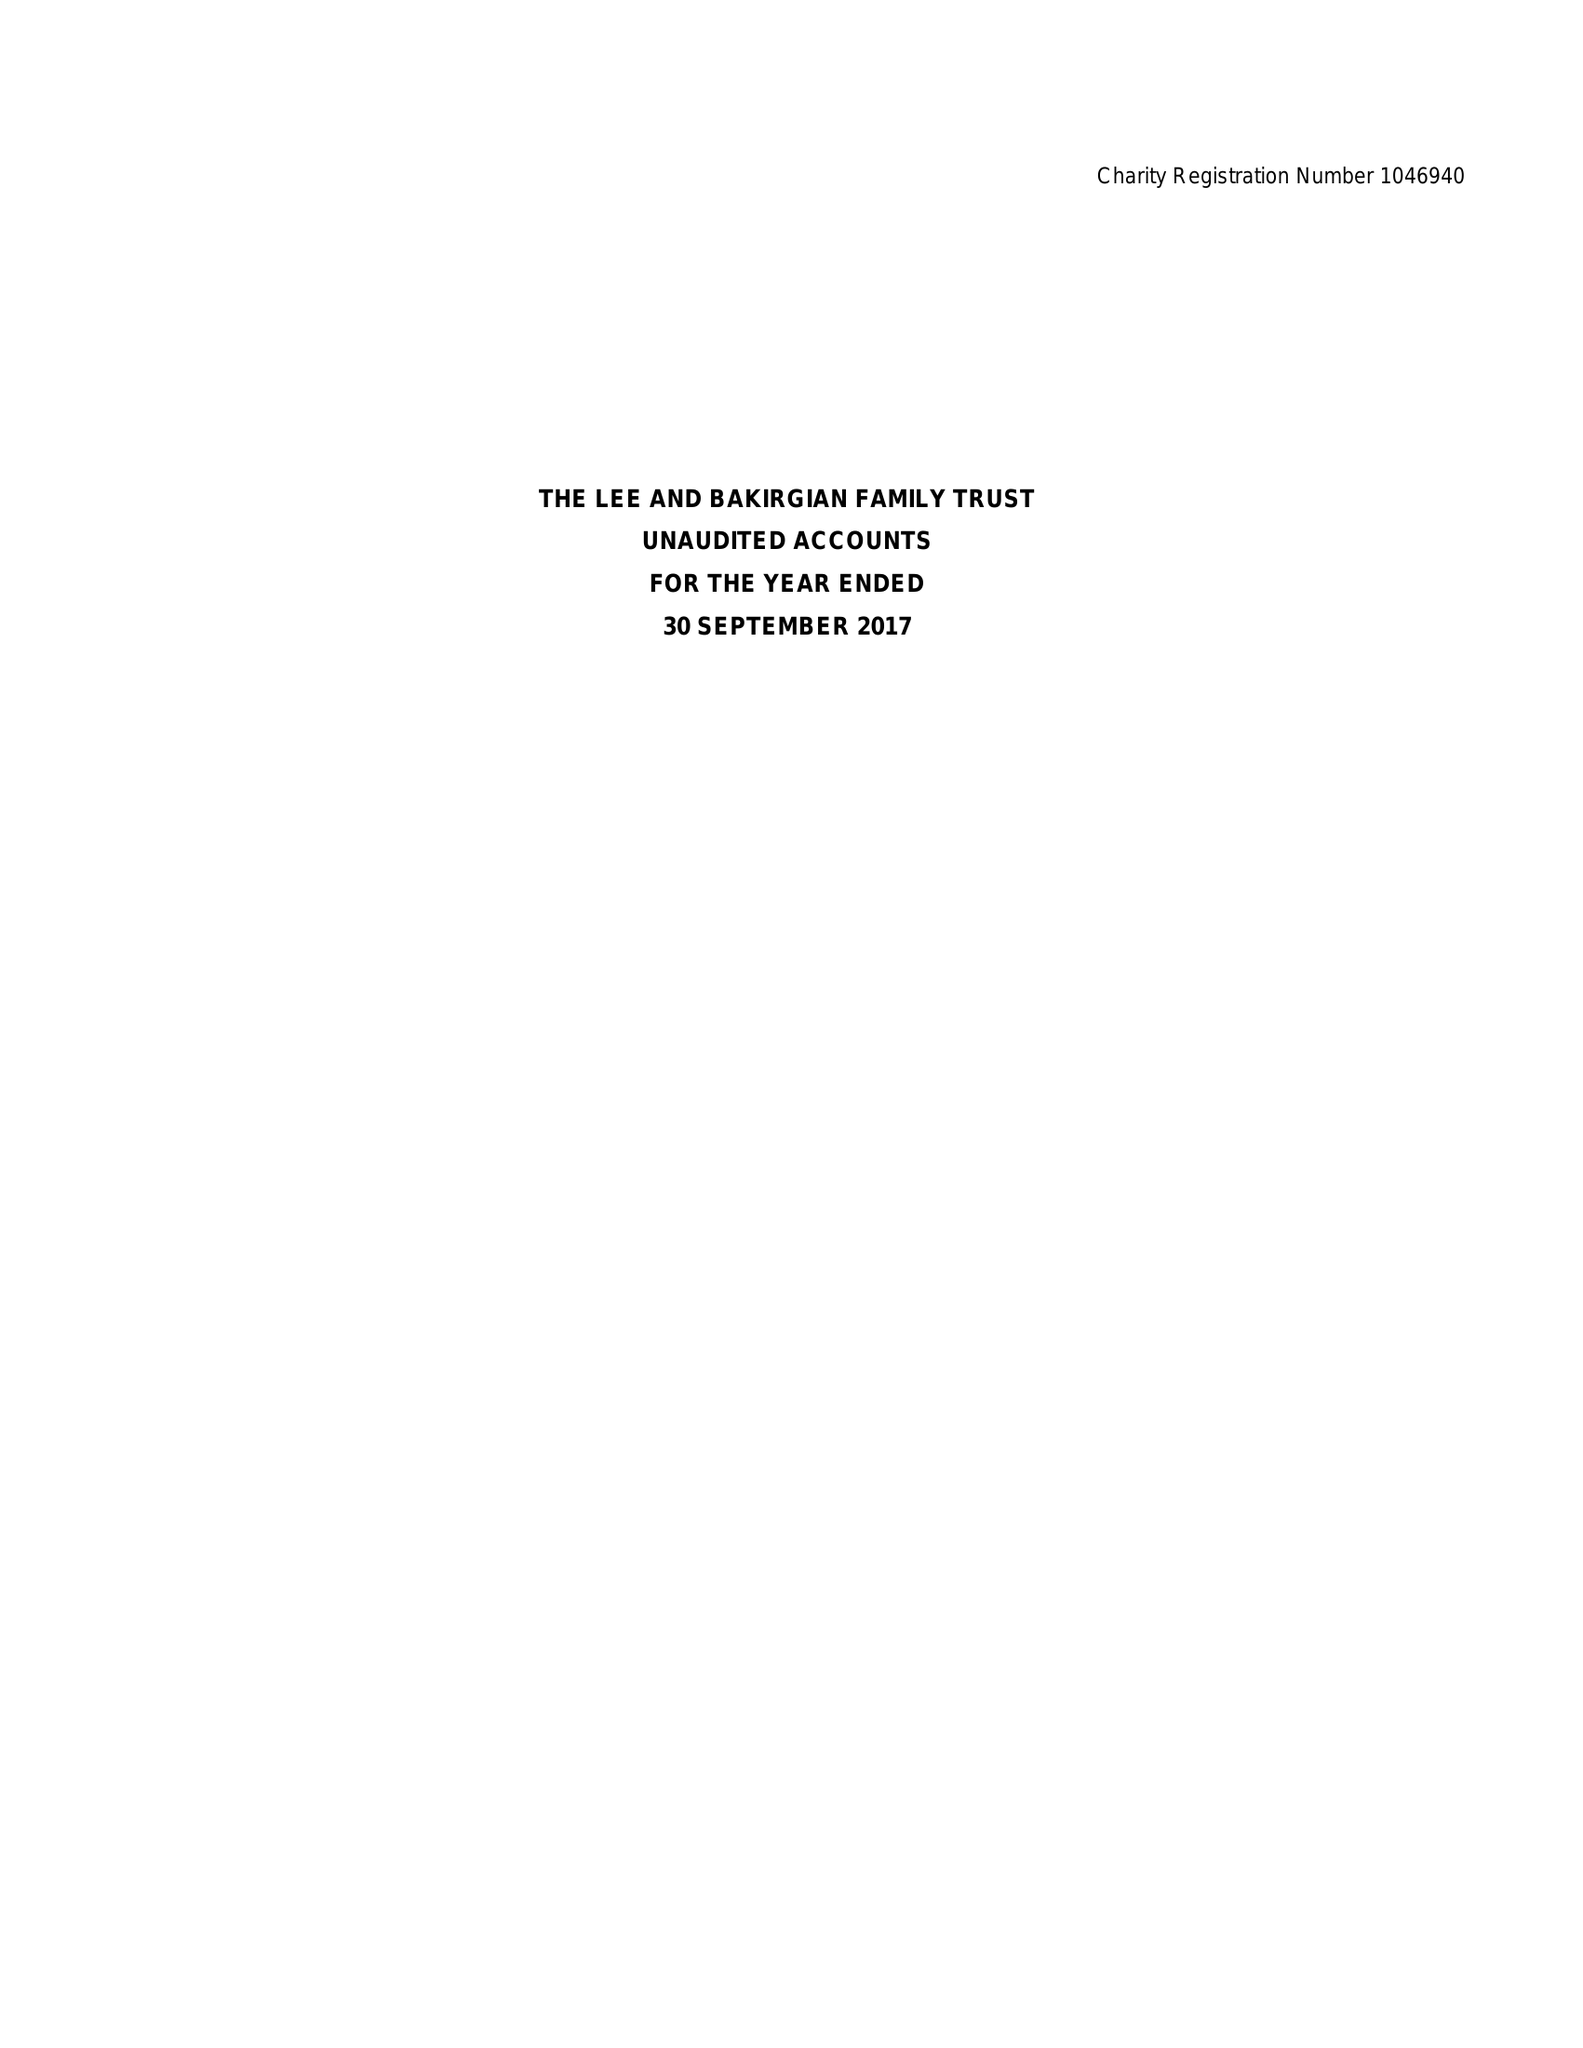What is the value for the address__post_town?
Answer the question using a single word or phrase. WARRINGTON 